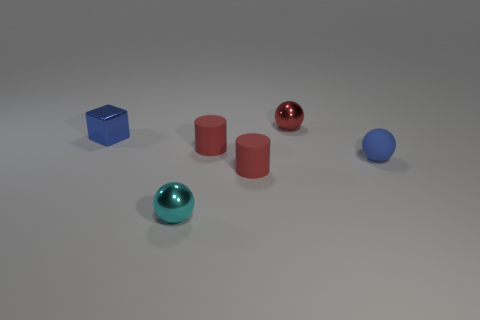There is a cyan object that is the same size as the red metal ball; what material is it?
Give a very brief answer. Metal. What shape is the red metal thing behind the object right of the tiny red metallic sphere behind the small cube?
Your answer should be very brief. Sphere. What shape is the other blue object that is the same size as the blue metallic object?
Your response must be concise. Sphere. How many small cyan metallic balls are on the right side of the small metal object that is to the left of the metal ball left of the red sphere?
Make the answer very short. 1. Are there more tiny red objects that are in front of the blue shiny thing than metal blocks that are on the right side of the blue matte sphere?
Offer a very short reply. Yes. How many other objects are the same shape as the blue shiny object?
Provide a succinct answer. 0. How many objects are things to the left of the matte ball or tiny red matte cylinders that are in front of the tiny rubber ball?
Give a very brief answer. 5. There is a sphere that is right of the tiny thing behind the blue object to the left of the tiny blue matte sphere; what is its material?
Your answer should be compact. Rubber. There is a rubber ball that is on the right side of the small red sphere; does it have the same color as the block?
Provide a short and direct response. Yes. What material is the ball that is both left of the rubber ball and in front of the small blue block?
Your answer should be very brief. Metal. 